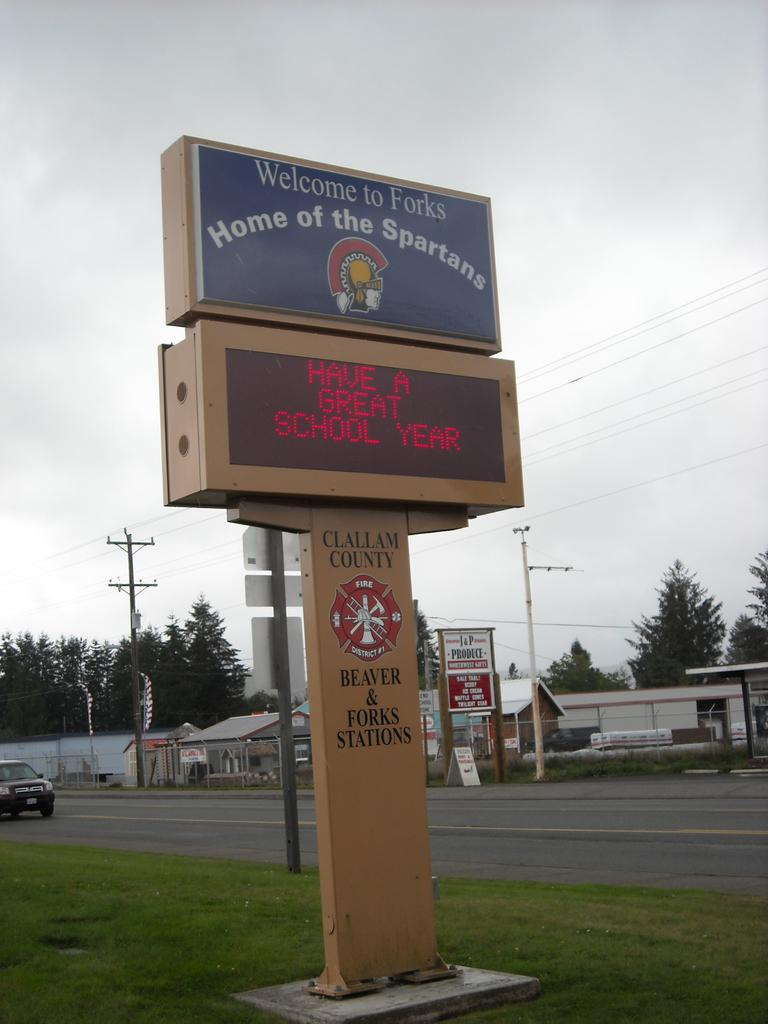Provide a one-sentence caption for the provided image. a school sign for the town of forks, home of the spartans. 